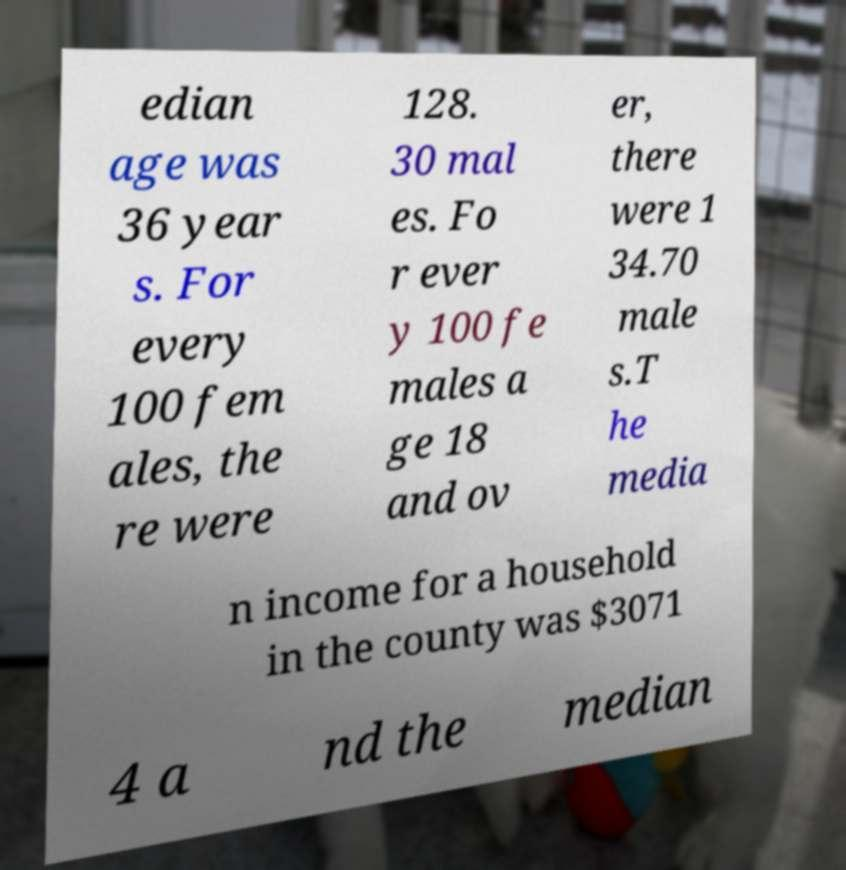I need the written content from this picture converted into text. Can you do that? edian age was 36 year s. For every 100 fem ales, the re were 128. 30 mal es. Fo r ever y 100 fe males a ge 18 and ov er, there were 1 34.70 male s.T he media n income for a household in the county was $3071 4 a nd the median 